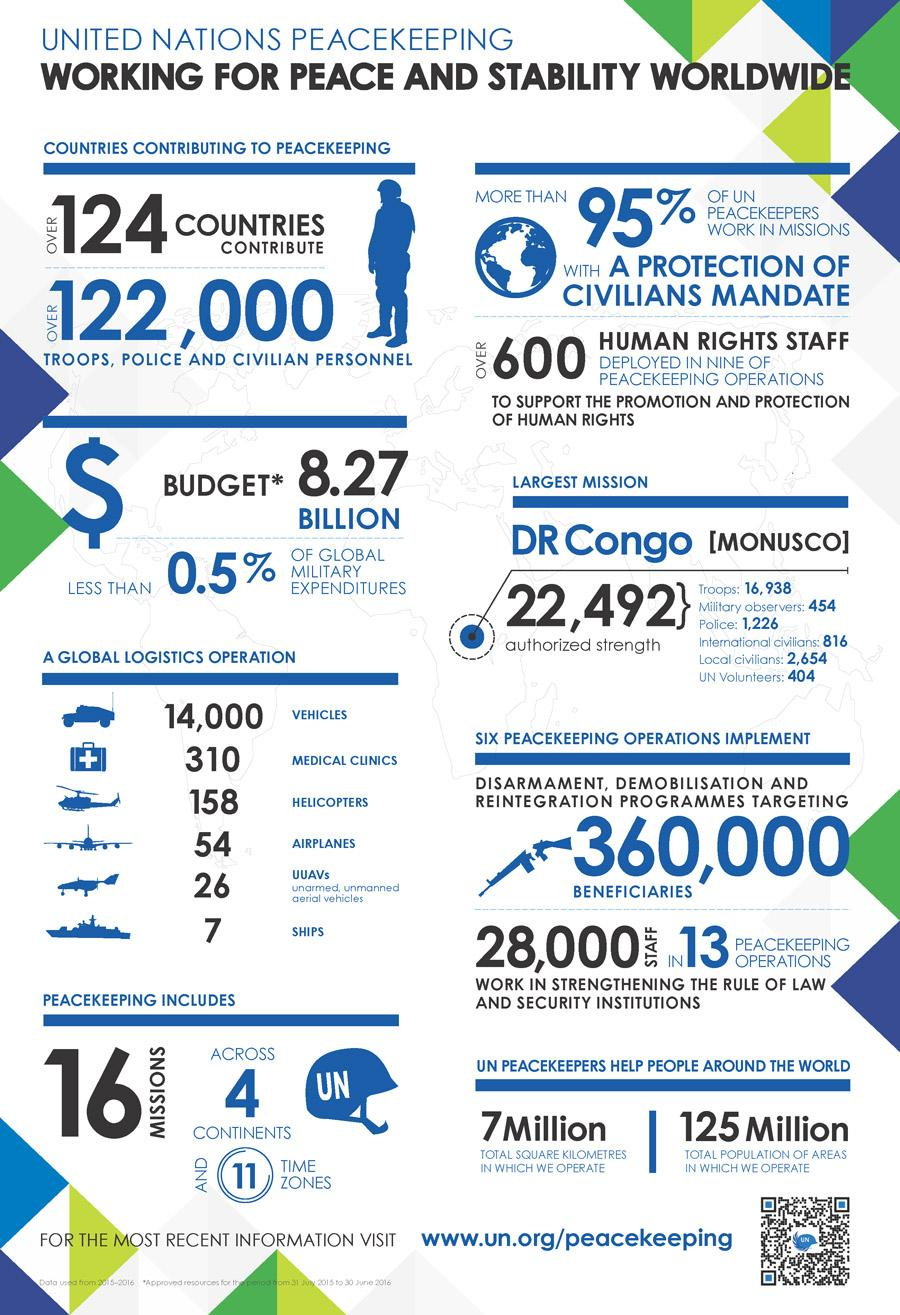Highlight a few significant elements in this photo. Seventy-one countries do not contribute to peacekeeping missions. It is estimated that only 3 continents are not included in peacekeeping operations. The UN peacekeeping force uses a total of 14,555 vehicles in its logistics operations. 